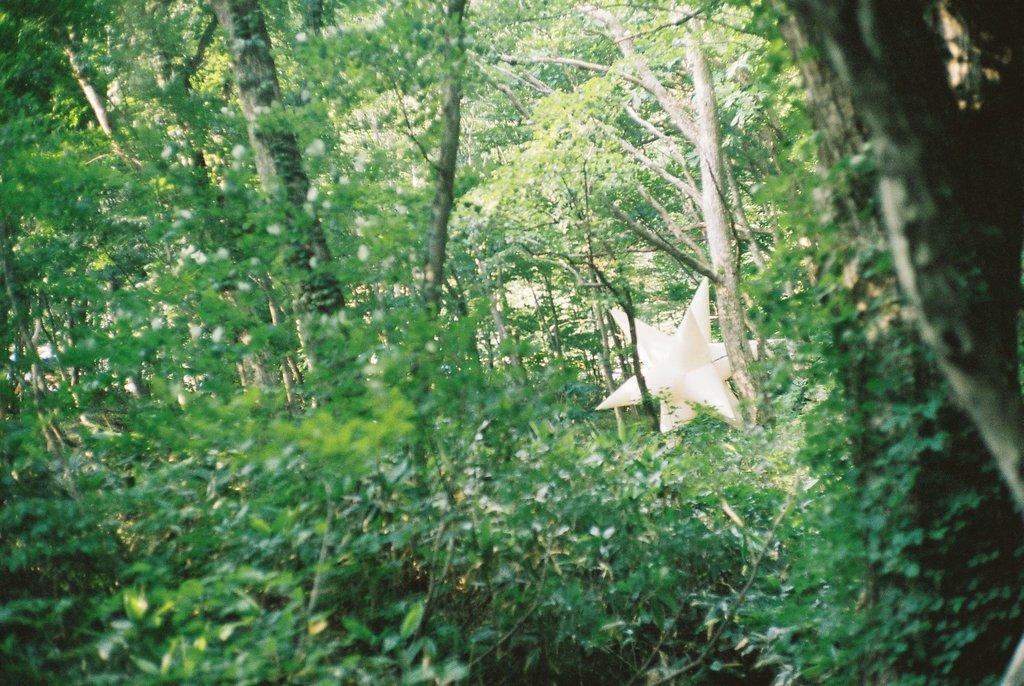How would you summarize this image in a sentence or two? On the left side, there are trees and plants on the ground. On the right side, there is a star and there are trees and plants on the ground. In the background, there are other trees. 